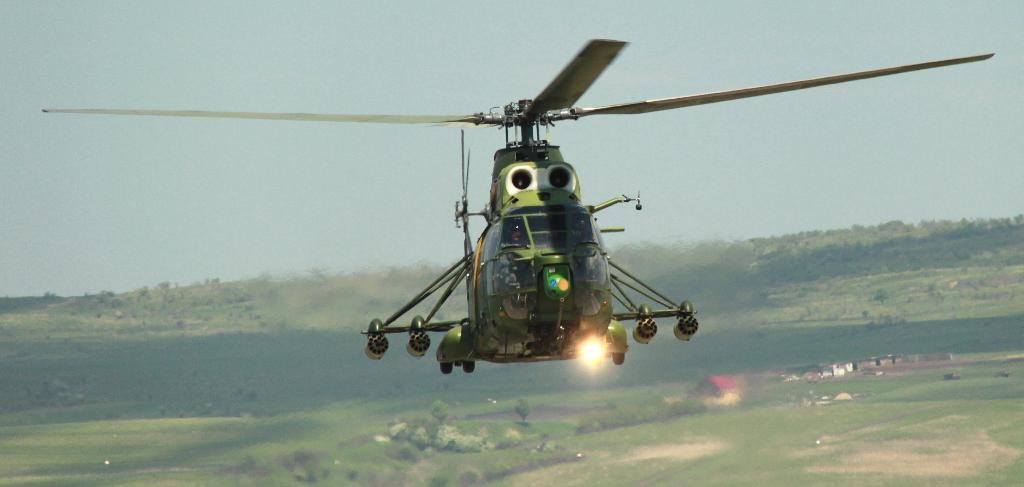What is flying in the sky in the image? There is a helicopter flying in the sky in the image. What type of vegetation can be seen in the image? There are trees visible in the image. What type of structures are present in the image? There are houses in the image. Where is the goat grazing in the image? There is no goat present in the image. What type of activity is happening during the recess in the image? There is no recess or any indication of an activity happening in the image. 